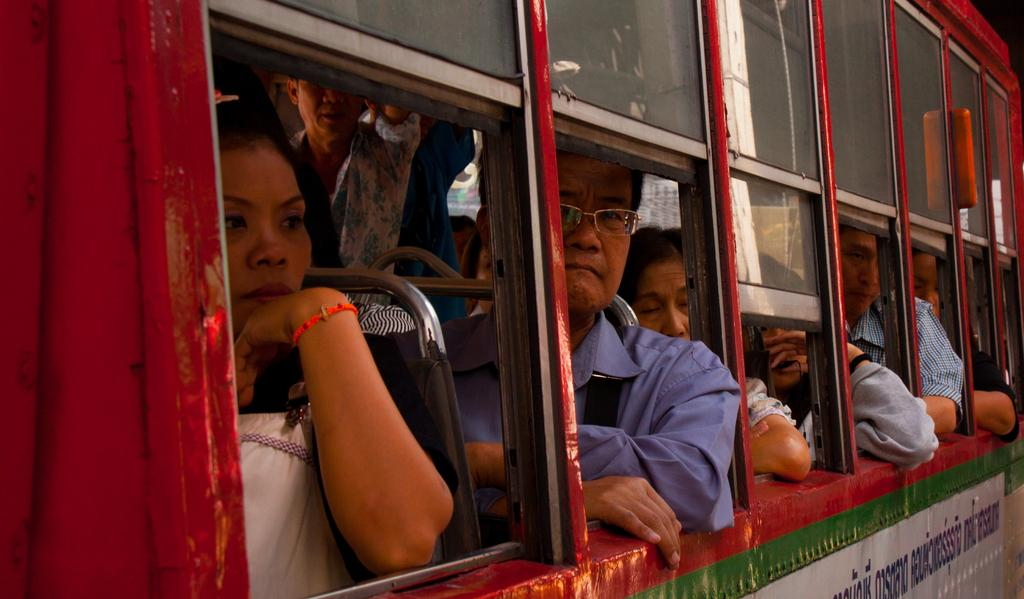What can be seen in the image? There are people in the image. What are the people doing in the image? The people are sitting and standing in a vehicle. What type of toys are the people playing with in the image? There are no toys present in the image; the people are sitting and standing in a vehicle. 